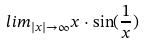Convert formula to latex. <formula><loc_0><loc_0><loc_500><loc_500>l i m _ { | x | \rightarrow \infty } x \cdot \sin ( \frac { 1 } { x } )</formula> 